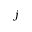<formula> <loc_0><loc_0><loc_500><loc_500>j</formula> 